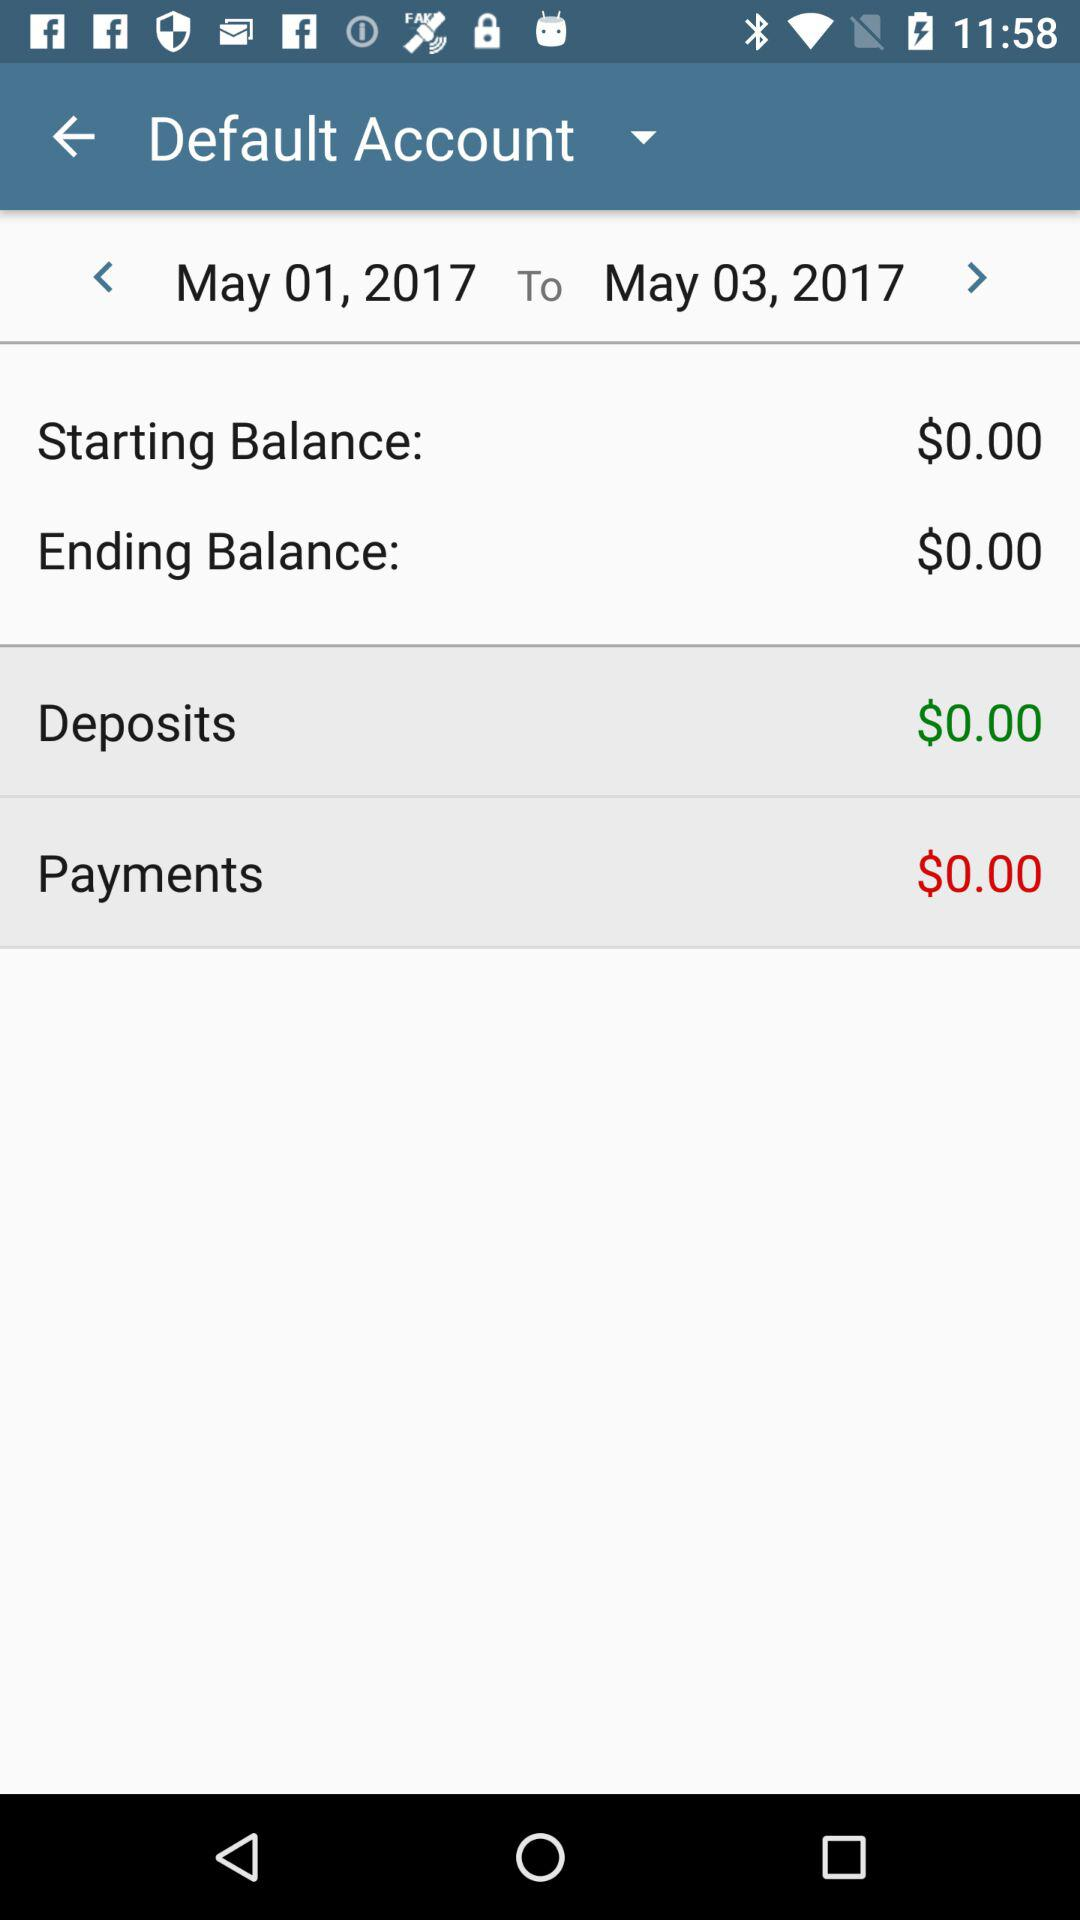What is the starting date? The starting date is May 1, 2017. 